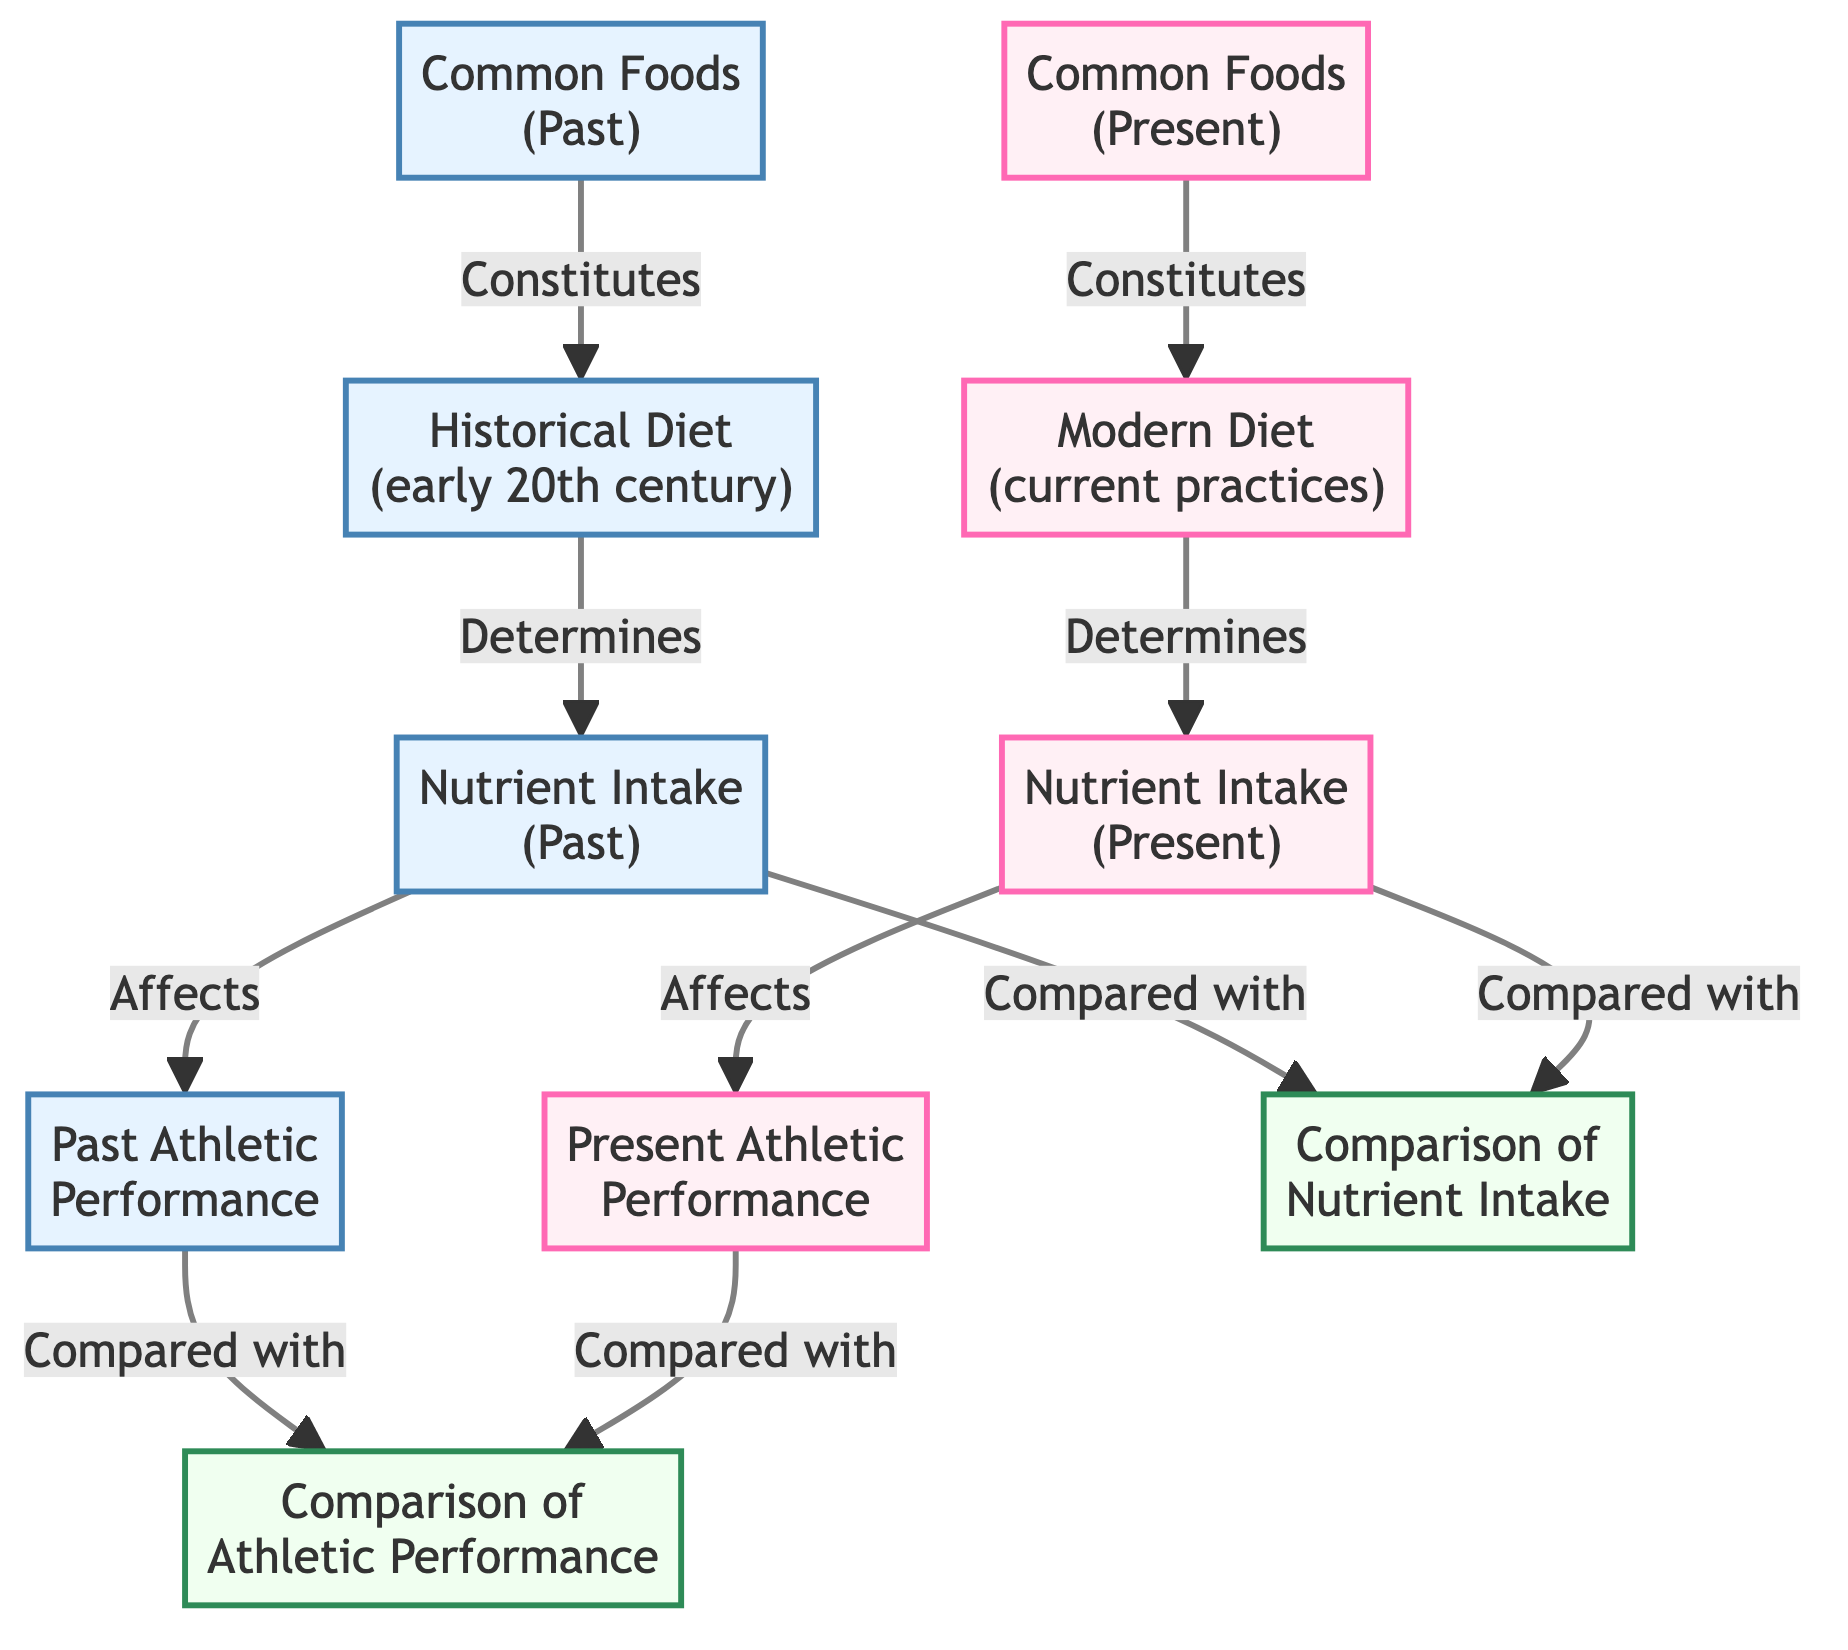What does the modern diet constitute? The modern diet is represented by the node labeled "Modern Diet (current practices)", which is directly connected to the node "Common Foods (Present)". Therefore, it constitutes the common foods consumed in present times.
Answer: Common Foods (Present) How many nodes are there in the past section of the diagram? The past section consists of the nodes: "Historical Diet", "Nutrient Intake (Past)", "Common Foods (Past)", and "Past Athletic Performance". This totals four nodes.
Answer: 4 What is the relationship between nutrient intake in the present and athletic performance? The node "Nutrient Intake (Present)" has a directed edge pointing to the node "Present Athletic Performance", indicating that nutrient intake in the present affects athletic performance.
Answer: Affects What do the common foods in the past determine? The common foods in the past are linked by an edge to the "Historical Diet" node, which means they determine the historical dietary patterns.
Answer: Historical Diet How does the past athletic performance relate to the comparison of athletic performance? The node "Past Athletic Performance" has a directed edge that indicates it is compared with the node "Comparison of Athletic Performance", showing a direct relationship for analysis.
Answer: Compared with What is present athletic performance compared with? The present athletic performance is linked with the node "Comparison of Athletic Performance", indicating that it is compared with the past athletic performance for analysis.
Answer: Comparison of Athletic Performance What does the nutrient intake in the past affect? The diagram shows a directed edge from "Nutrient Intake (Past)" to "Past Athletic Performance", signifying that it directly affects past athletic performance.
Answer: Past Athletic Performance How many comparisons are made in total in this diagram? The diagram indicates that both athletic performance and nutrient intake (past and present) are compared, totaling four comparisons: two for athletic performance and two for nutrient intake.
Answer: 4 